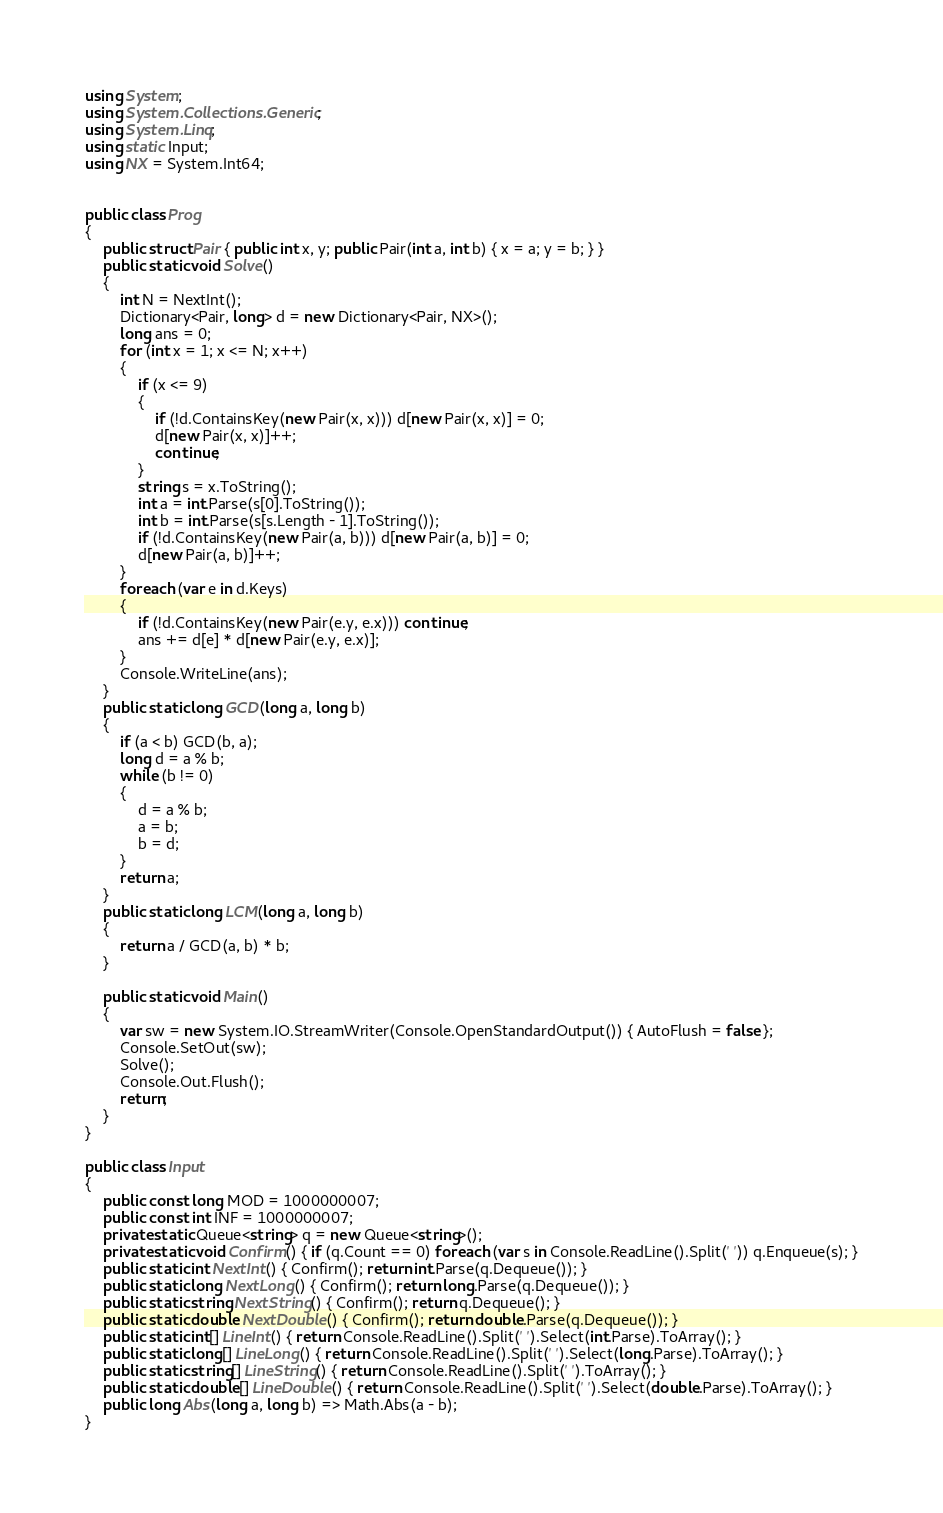Convert code to text. <code><loc_0><loc_0><loc_500><loc_500><_C#_>using System;
using System.Collections.Generic;
using System.Linq;
using static Input;
using NX = System.Int64;


public class Prog
{
    public struct Pair { public int x, y; public Pair(int a, int b) { x = a; y = b; } }
    public static void Solve()
    {
        int N = NextInt();
        Dictionary<Pair, long> d = new Dictionary<Pair, NX>();
        long ans = 0;
        for (int x = 1; x <= N; x++)
        {
            if (x <= 9)
            {
                if (!d.ContainsKey(new Pair(x, x))) d[new Pair(x, x)] = 0;
                d[new Pair(x, x)]++;
                continue;
            }
            string s = x.ToString();
            int a = int.Parse(s[0].ToString());
            int b = int.Parse(s[s.Length - 1].ToString());
            if (!d.ContainsKey(new Pair(a, b))) d[new Pair(a, b)] = 0;
            d[new Pair(a, b)]++;
        }
        foreach (var e in d.Keys)
        {
            if (!d.ContainsKey(new Pair(e.y, e.x))) continue;
            ans += d[e] * d[new Pair(e.y, e.x)];
        }
        Console.WriteLine(ans);
    }
    public static long GCD(long a, long b)
    {
        if (a < b) GCD(b, a);
        long d = a % b;
        while (b != 0)
        {
            d = a % b;
            a = b;
            b = d;
        }
        return a;
    }
    public static long LCM(long a, long b)
    {
        return a / GCD(a, b) * b;
    }

    public static void Main()
    {
        var sw = new System.IO.StreamWriter(Console.OpenStandardOutput()) { AutoFlush = false };
        Console.SetOut(sw);
        Solve();
        Console.Out.Flush();
        return;
    }
}

public class Input
{
    public const long MOD = 1000000007;
    public const int INF = 1000000007;
    private static Queue<string> q = new Queue<string>();
    private static void Confirm() { if (q.Count == 0) foreach (var s in Console.ReadLine().Split(' ')) q.Enqueue(s); }
    public static int NextInt() { Confirm(); return int.Parse(q.Dequeue()); }
    public static long NextLong() { Confirm(); return long.Parse(q.Dequeue()); }
    public static string NextString() { Confirm(); return q.Dequeue(); }
    public static double NextDouble() { Confirm(); return double.Parse(q.Dequeue()); }
    public static int[] LineInt() { return Console.ReadLine().Split(' ').Select(int.Parse).ToArray(); }
    public static long[] LineLong() { return Console.ReadLine().Split(' ').Select(long.Parse).ToArray(); }
    public static string[] LineString() { return Console.ReadLine().Split(' ').ToArray(); }
    public static double[] LineDouble() { return Console.ReadLine().Split(' ').Select(double.Parse).ToArray(); }
    public long Abs(long a, long b) => Math.Abs(a - b);
}
</code> 